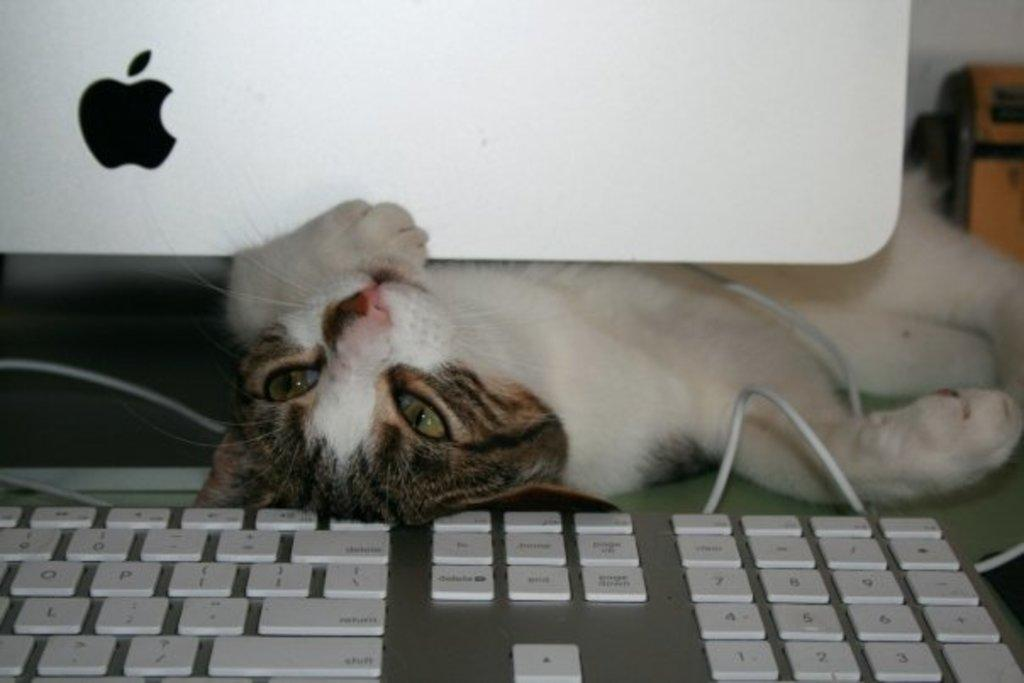What type of animal is in the picture? There is a cat in the picture. What electronic device is visible in the picture? There is a monitor in the picture. What other computer accessory is present in the image? There is a keyboard in the picture. What type of zebra can be seen in the picture? There is no zebra present in the picture; it features a cat, monitor, and keyboard. What time of day is depicted in the image? The time of day cannot be determined from the image, as there are no clues or indicators of the time. 